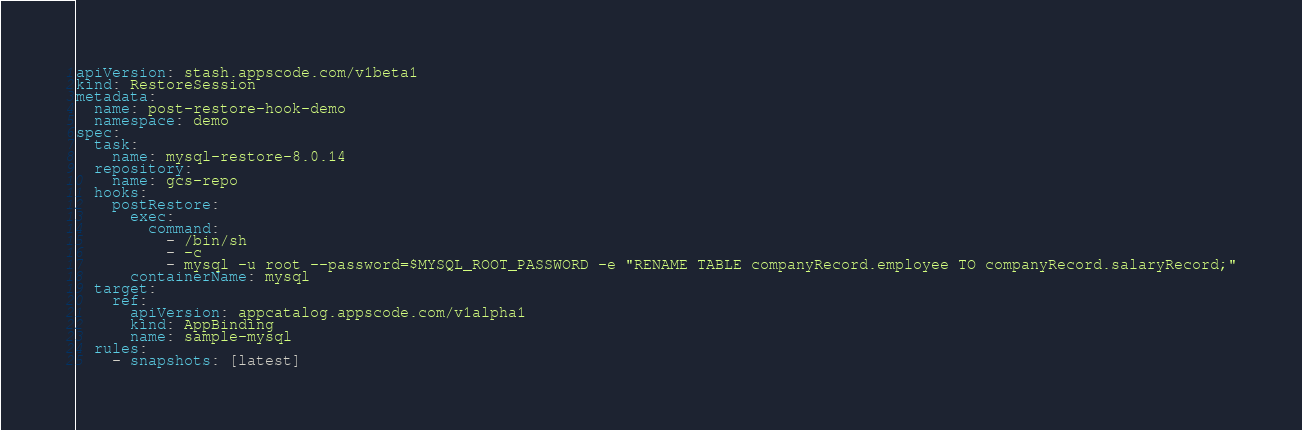Convert code to text. <code><loc_0><loc_0><loc_500><loc_500><_YAML_>apiVersion: stash.appscode.com/v1beta1
kind: RestoreSession
metadata:
  name: post-restore-hook-demo
  namespace: demo
spec:
  task:
    name: mysql-restore-8.0.14
  repository:
    name: gcs-repo
  hooks:
    postRestore:
      exec:
        command:
          - /bin/sh
          - -c
          - mysql -u root --password=$MYSQL_ROOT_PASSWORD -e "RENAME TABLE companyRecord.employee TO companyRecord.salaryRecord;"
      containerName: mysql
  target:
    ref:
      apiVersion: appcatalog.appscode.com/v1alpha1
      kind: AppBinding
      name: sample-mysql
  rules:
    - snapshots: [latest]
</code> 